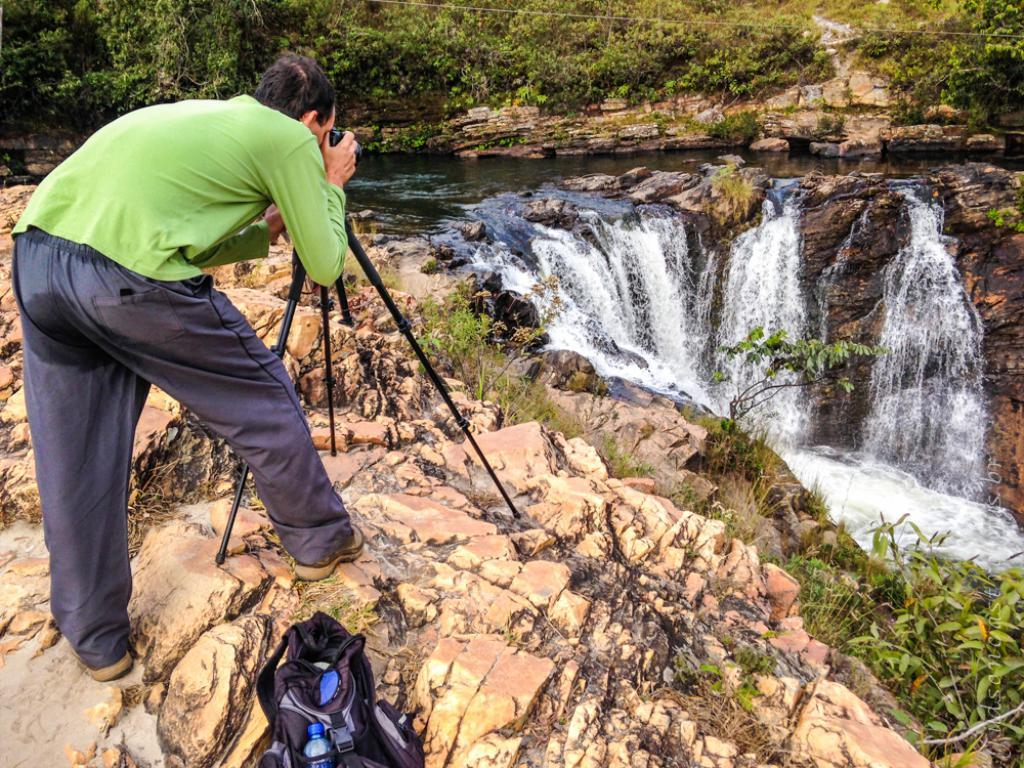Who is present in the image? There is a man in the image. What is the man doing in the image? The man is standing on rocks and holding a camera with his hands. What else can be seen in the image? There is a bag and a tripod stand in the image. What is the setting of the image? There is water visible in the image, and there are trees in the background. What type of love can be seen between the man and the woman in the image? There is no woman present in the image, and therefore no interaction between a man and a woman can be observed. What is the man using the rod for in the image? There is no rod present in the image; the man is holding a camera. 